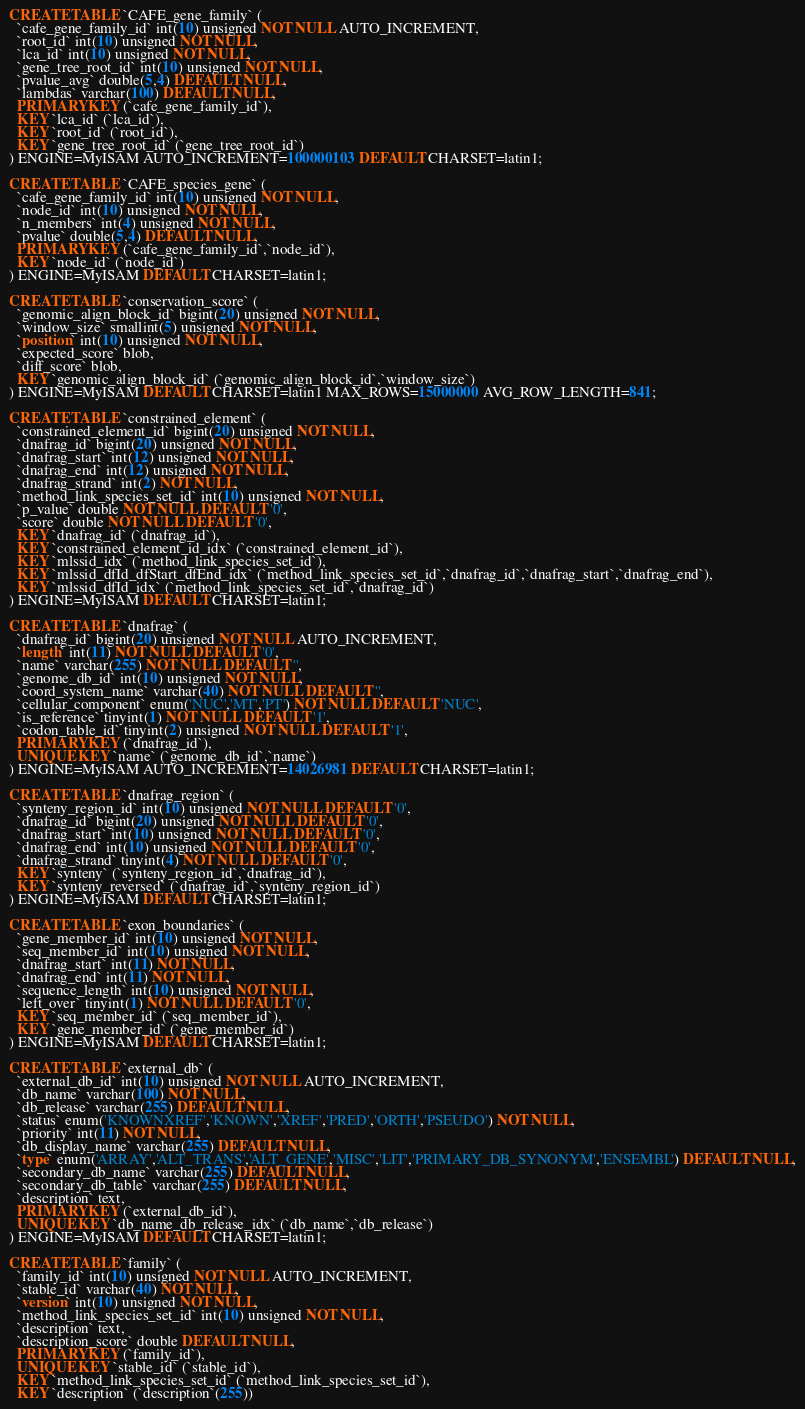<code> <loc_0><loc_0><loc_500><loc_500><_SQL_>CREATE TABLE `CAFE_gene_family` (
  `cafe_gene_family_id` int(10) unsigned NOT NULL AUTO_INCREMENT,
  `root_id` int(10) unsigned NOT NULL,
  `lca_id` int(10) unsigned NOT NULL,
  `gene_tree_root_id` int(10) unsigned NOT NULL,
  `pvalue_avg` double(5,4) DEFAULT NULL,
  `lambdas` varchar(100) DEFAULT NULL,
  PRIMARY KEY (`cafe_gene_family_id`),
  KEY `lca_id` (`lca_id`),
  KEY `root_id` (`root_id`),
  KEY `gene_tree_root_id` (`gene_tree_root_id`)
) ENGINE=MyISAM AUTO_INCREMENT=100000103 DEFAULT CHARSET=latin1;

CREATE TABLE `CAFE_species_gene` (
  `cafe_gene_family_id` int(10) unsigned NOT NULL,
  `node_id` int(10) unsigned NOT NULL,
  `n_members` int(4) unsigned NOT NULL,
  `pvalue` double(5,4) DEFAULT NULL,
  PRIMARY KEY (`cafe_gene_family_id`,`node_id`),
  KEY `node_id` (`node_id`)
) ENGINE=MyISAM DEFAULT CHARSET=latin1;

CREATE TABLE `conservation_score` (
  `genomic_align_block_id` bigint(20) unsigned NOT NULL,
  `window_size` smallint(5) unsigned NOT NULL,
  `position` int(10) unsigned NOT NULL,
  `expected_score` blob,
  `diff_score` blob,
  KEY `genomic_align_block_id` (`genomic_align_block_id`,`window_size`)
) ENGINE=MyISAM DEFAULT CHARSET=latin1 MAX_ROWS=15000000 AVG_ROW_LENGTH=841;

CREATE TABLE `constrained_element` (
  `constrained_element_id` bigint(20) unsigned NOT NULL,
  `dnafrag_id` bigint(20) unsigned NOT NULL,
  `dnafrag_start` int(12) unsigned NOT NULL,
  `dnafrag_end` int(12) unsigned NOT NULL,
  `dnafrag_strand` int(2) NOT NULL,
  `method_link_species_set_id` int(10) unsigned NOT NULL,
  `p_value` double NOT NULL DEFAULT '0',
  `score` double NOT NULL DEFAULT '0',
  KEY `dnafrag_id` (`dnafrag_id`),
  KEY `constrained_element_id_idx` (`constrained_element_id`),
  KEY `mlssid_idx` (`method_link_species_set_id`),
  KEY `mlssid_dfId_dfStart_dfEnd_idx` (`method_link_species_set_id`,`dnafrag_id`,`dnafrag_start`,`dnafrag_end`),
  KEY `mlssid_dfId_idx` (`method_link_species_set_id`,`dnafrag_id`)
) ENGINE=MyISAM DEFAULT CHARSET=latin1;

CREATE TABLE `dnafrag` (
  `dnafrag_id` bigint(20) unsigned NOT NULL AUTO_INCREMENT,
  `length` int(11) NOT NULL DEFAULT '0',
  `name` varchar(255) NOT NULL DEFAULT '',
  `genome_db_id` int(10) unsigned NOT NULL,
  `coord_system_name` varchar(40) NOT NULL DEFAULT '',
  `cellular_component` enum('NUC','MT','PT') NOT NULL DEFAULT 'NUC',
  `is_reference` tinyint(1) NOT NULL DEFAULT '1',
  `codon_table_id` tinyint(2) unsigned NOT NULL DEFAULT '1',
  PRIMARY KEY (`dnafrag_id`),
  UNIQUE KEY `name` (`genome_db_id`,`name`)
) ENGINE=MyISAM AUTO_INCREMENT=14026981 DEFAULT CHARSET=latin1;

CREATE TABLE `dnafrag_region` (
  `synteny_region_id` int(10) unsigned NOT NULL DEFAULT '0',
  `dnafrag_id` bigint(20) unsigned NOT NULL DEFAULT '0',
  `dnafrag_start` int(10) unsigned NOT NULL DEFAULT '0',
  `dnafrag_end` int(10) unsigned NOT NULL DEFAULT '0',
  `dnafrag_strand` tinyint(4) NOT NULL DEFAULT '0',
  KEY `synteny` (`synteny_region_id`,`dnafrag_id`),
  KEY `synteny_reversed` (`dnafrag_id`,`synteny_region_id`)
) ENGINE=MyISAM DEFAULT CHARSET=latin1;

CREATE TABLE `exon_boundaries` (
  `gene_member_id` int(10) unsigned NOT NULL,
  `seq_member_id` int(10) unsigned NOT NULL,
  `dnafrag_start` int(11) NOT NULL,
  `dnafrag_end` int(11) NOT NULL,
  `sequence_length` int(10) unsigned NOT NULL,
  `left_over` tinyint(1) NOT NULL DEFAULT '0',
  KEY `seq_member_id` (`seq_member_id`),
  KEY `gene_member_id` (`gene_member_id`)
) ENGINE=MyISAM DEFAULT CHARSET=latin1;

CREATE TABLE `external_db` (
  `external_db_id` int(10) unsigned NOT NULL AUTO_INCREMENT,
  `db_name` varchar(100) NOT NULL,
  `db_release` varchar(255) DEFAULT NULL,
  `status` enum('KNOWNXREF','KNOWN','XREF','PRED','ORTH','PSEUDO') NOT NULL,
  `priority` int(11) NOT NULL,
  `db_display_name` varchar(255) DEFAULT NULL,
  `type` enum('ARRAY','ALT_TRANS','ALT_GENE','MISC','LIT','PRIMARY_DB_SYNONYM','ENSEMBL') DEFAULT NULL,
  `secondary_db_name` varchar(255) DEFAULT NULL,
  `secondary_db_table` varchar(255) DEFAULT NULL,
  `description` text,
  PRIMARY KEY (`external_db_id`),
  UNIQUE KEY `db_name_db_release_idx` (`db_name`,`db_release`)
) ENGINE=MyISAM DEFAULT CHARSET=latin1;

CREATE TABLE `family` (
  `family_id` int(10) unsigned NOT NULL AUTO_INCREMENT,
  `stable_id` varchar(40) NOT NULL,
  `version` int(10) unsigned NOT NULL,
  `method_link_species_set_id` int(10) unsigned NOT NULL,
  `description` text,
  `description_score` double DEFAULT NULL,
  PRIMARY KEY (`family_id`),
  UNIQUE KEY `stable_id` (`stable_id`),
  KEY `method_link_species_set_id` (`method_link_species_set_id`),
  KEY `description` (`description`(255))</code> 